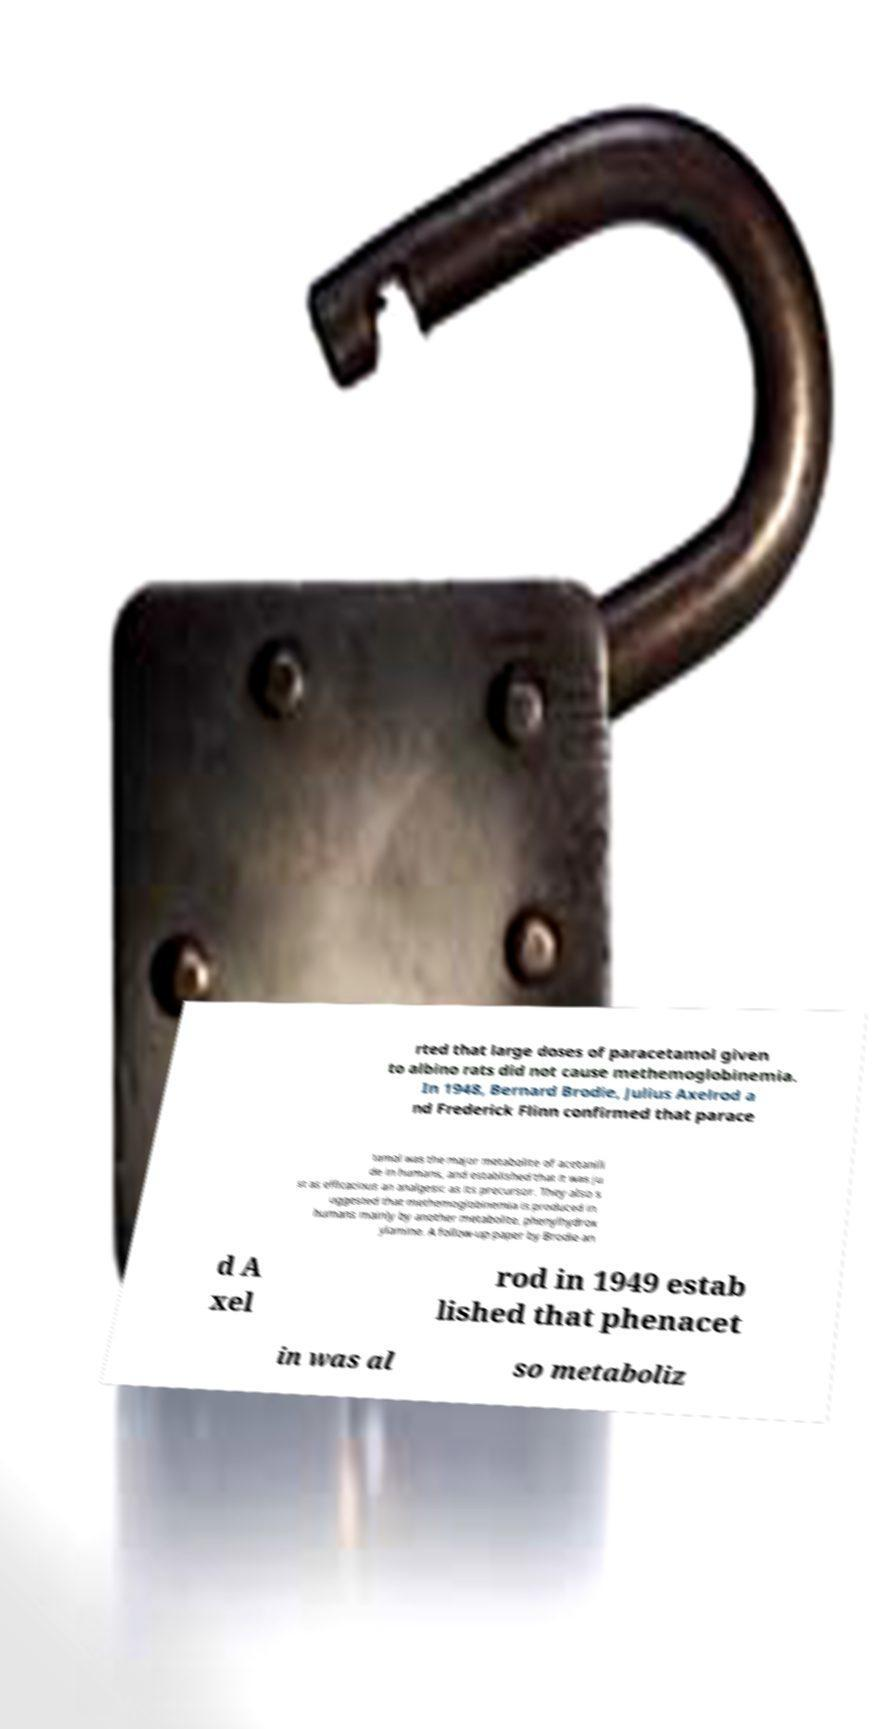Please identify and transcribe the text found in this image. rted that large doses of paracetamol given to albino rats did not cause methemoglobinemia. In 1948, Bernard Brodie, Julius Axelrod a nd Frederick Flinn confirmed that parace tamol was the major metabolite of acetanili de in humans, and established that it was ju st as efficacious an analgesic as its precursor. They also s uggested that methemoglobinemia is produced in humans mainly by another metabolite, phenylhydrox ylamine. A follow-up paper by Brodie an d A xel rod in 1949 estab lished that phenacet in was al so metaboliz 